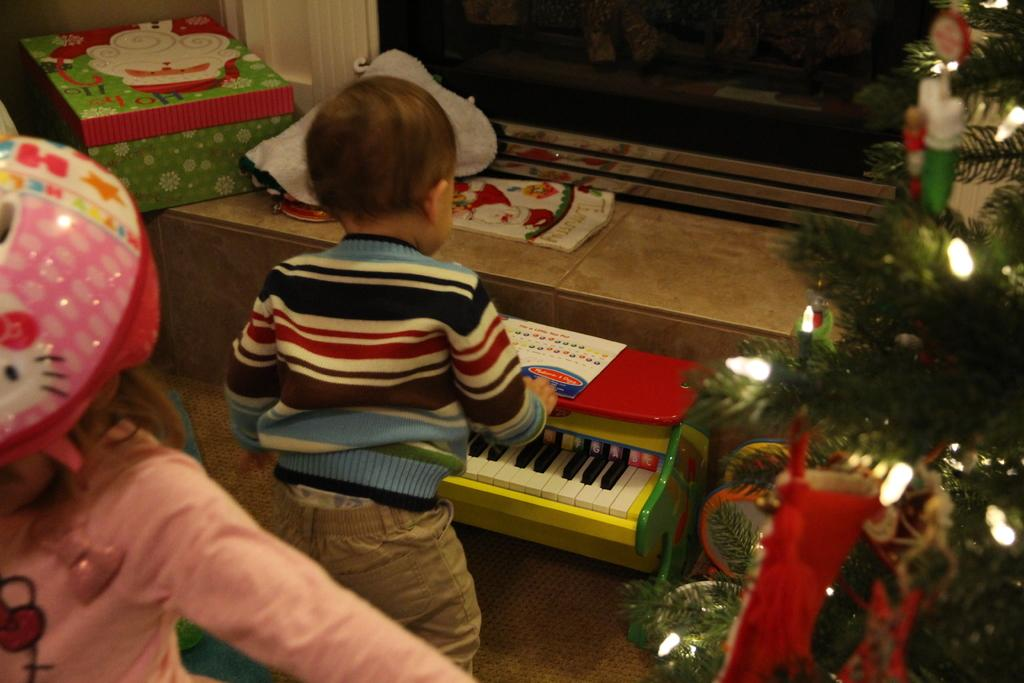Who is the main subject in the image? There is a little boy in the image. What is the little boy doing in the image? The little boy is playing with a piano. What additional element is present in the image that is related to a holiday? There is a Christmas tree in the image. What feature of the Christmas tree is mentioned in the facts? The Christmas tree has lights on it. What type of food is the little boy eating while playing the piano? There is no food present in the image; the little boy is playing with a piano. How does the piano affect the little boy's nerves in the image? There is no indication in the image that the piano is affecting the little boy's nerves. 